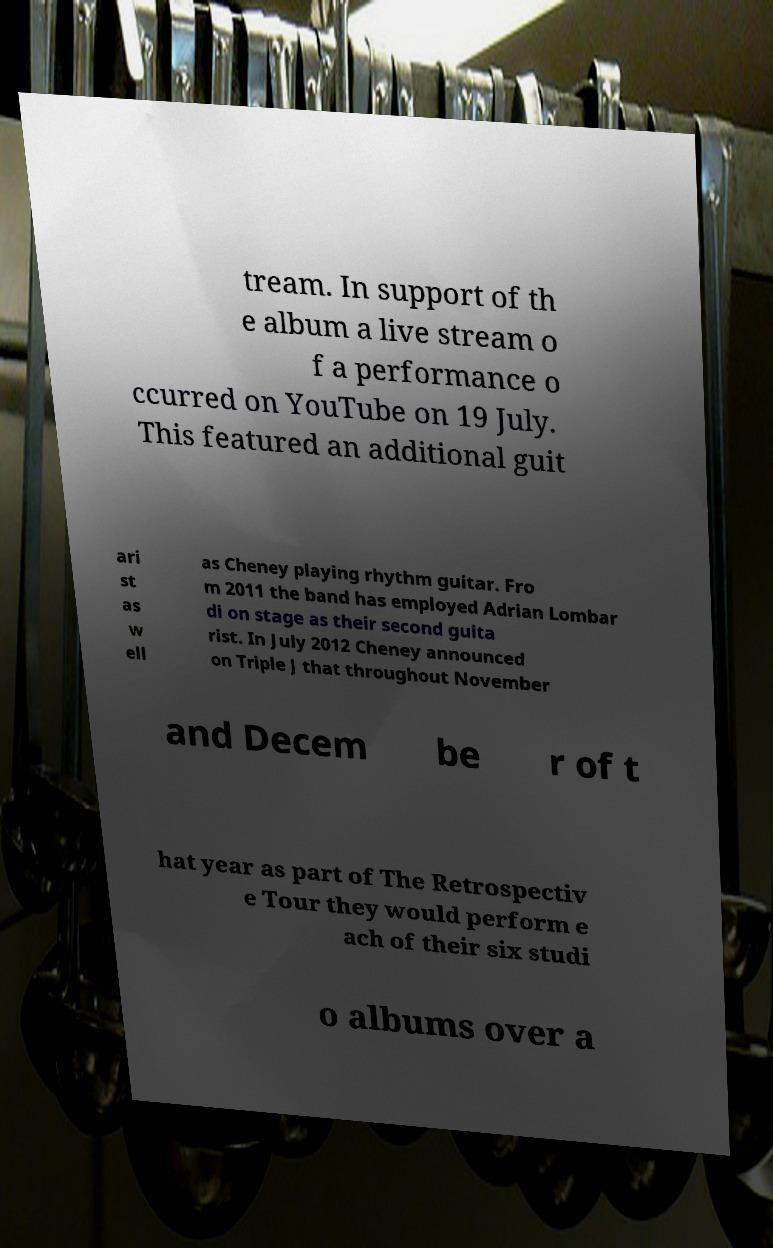Could you extract and type out the text from this image? tream. In support of th e album a live stream o f a performance o ccurred on YouTube on 19 July. This featured an additional guit ari st as w ell as Cheney playing rhythm guitar. Fro m 2011 the band has employed Adrian Lombar di on stage as their second guita rist. In July 2012 Cheney announced on Triple J that throughout November and Decem be r of t hat year as part of The Retrospectiv e Tour they would perform e ach of their six studi o albums over a 